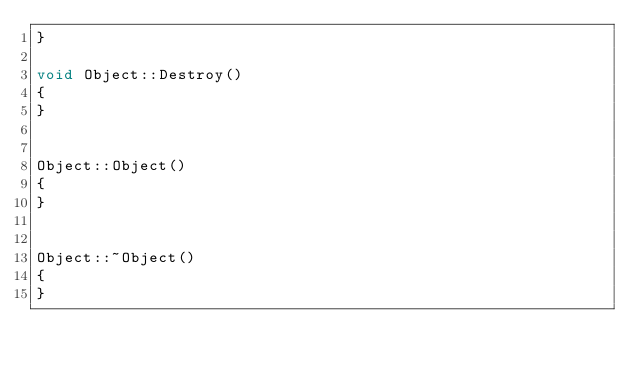Convert code to text. <code><loc_0><loc_0><loc_500><loc_500><_C++_>}

void Object::Destroy()
{
}


Object::Object()
{
}


Object::~Object()
{
}
</code> 